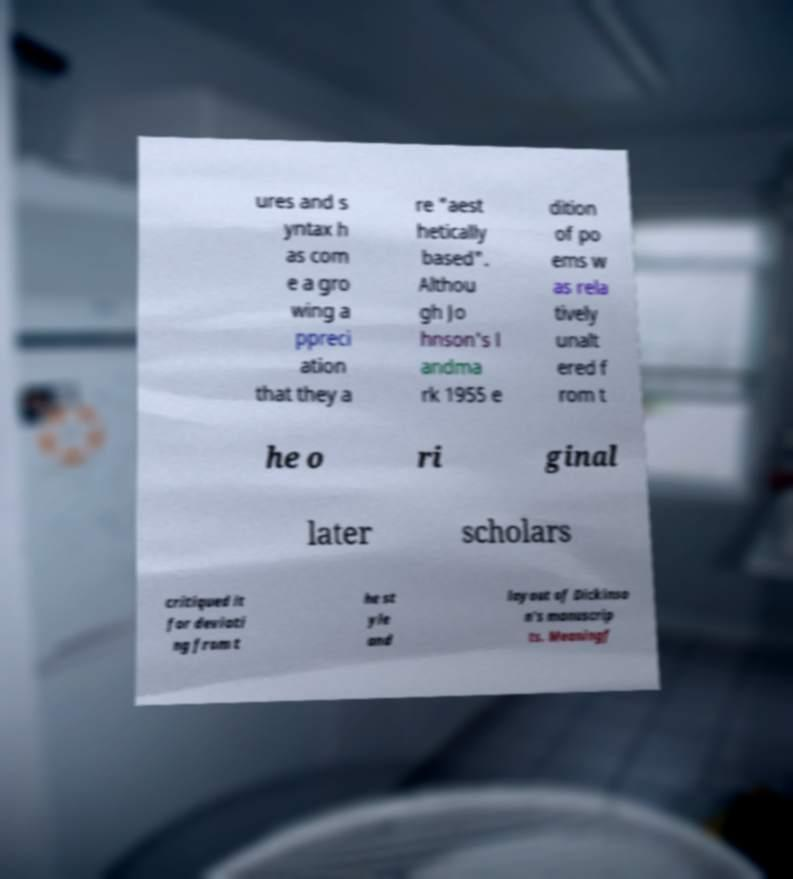There's text embedded in this image that I need extracted. Can you transcribe it verbatim? ures and s yntax h as com e a gro wing a ppreci ation that they a re "aest hetically based". Althou gh Jo hnson's l andma rk 1955 e dition of po ems w as rela tively unalt ered f rom t he o ri ginal later scholars critiqued it for deviati ng from t he st yle and layout of Dickinso n's manuscrip ts. Meaningf 